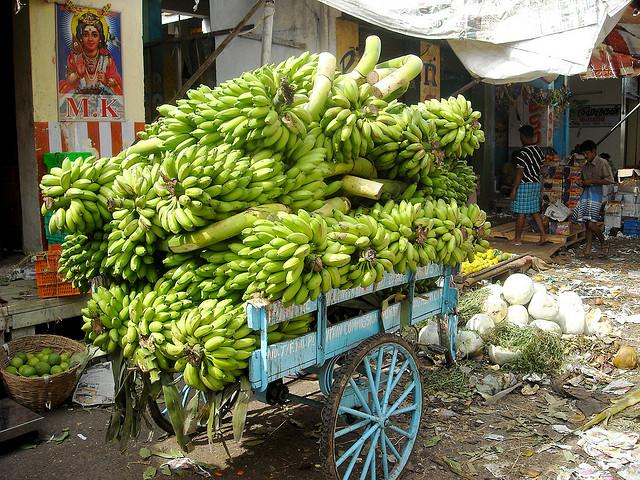What religion is common in this area?

Choices:
A) christianity
B) judaism
C) islam
D) hinduism hinduism 